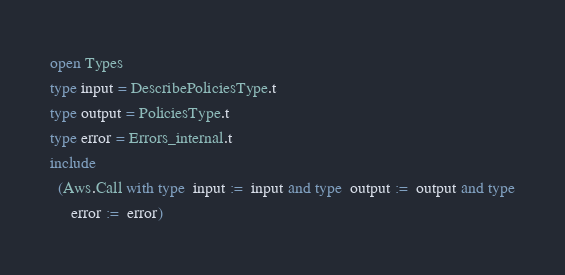Convert code to text. <code><loc_0><loc_0><loc_500><loc_500><_OCaml_>open Types
type input = DescribePoliciesType.t
type output = PoliciesType.t
type error = Errors_internal.t
include
  (Aws.Call with type  input :=  input and type  output :=  output and type
     error :=  error)</code> 